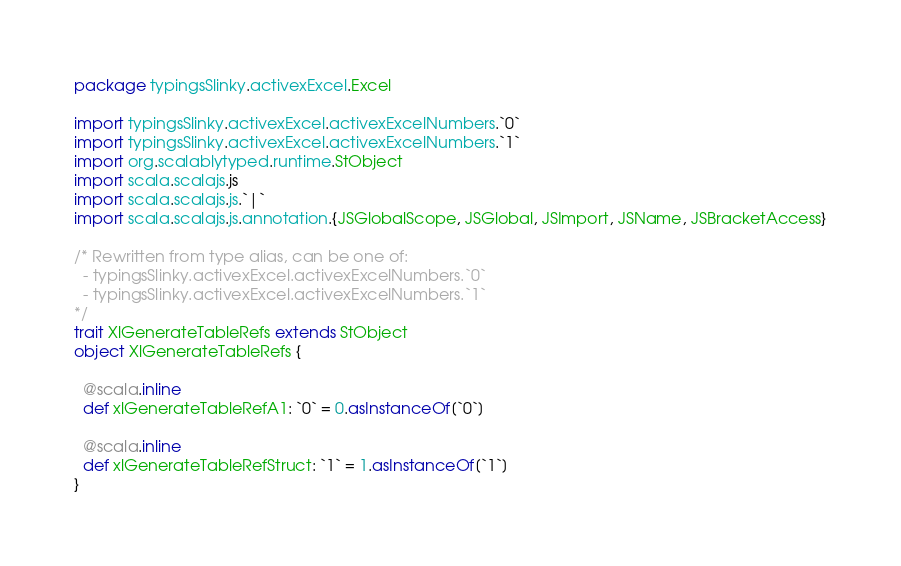Convert code to text. <code><loc_0><loc_0><loc_500><loc_500><_Scala_>package typingsSlinky.activexExcel.Excel

import typingsSlinky.activexExcel.activexExcelNumbers.`0`
import typingsSlinky.activexExcel.activexExcelNumbers.`1`
import org.scalablytyped.runtime.StObject
import scala.scalajs.js
import scala.scalajs.js.`|`
import scala.scalajs.js.annotation.{JSGlobalScope, JSGlobal, JSImport, JSName, JSBracketAccess}

/* Rewritten from type alias, can be one of: 
  - typingsSlinky.activexExcel.activexExcelNumbers.`0`
  - typingsSlinky.activexExcel.activexExcelNumbers.`1`
*/
trait XlGenerateTableRefs extends StObject
object XlGenerateTableRefs {
  
  @scala.inline
  def xlGenerateTableRefA1: `0` = 0.asInstanceOf[`0`]
  
  @scala.inline
  def xlGenerateTableRefStruct: `1` = 1.asInstanceOf[`1`]
}
</code> 